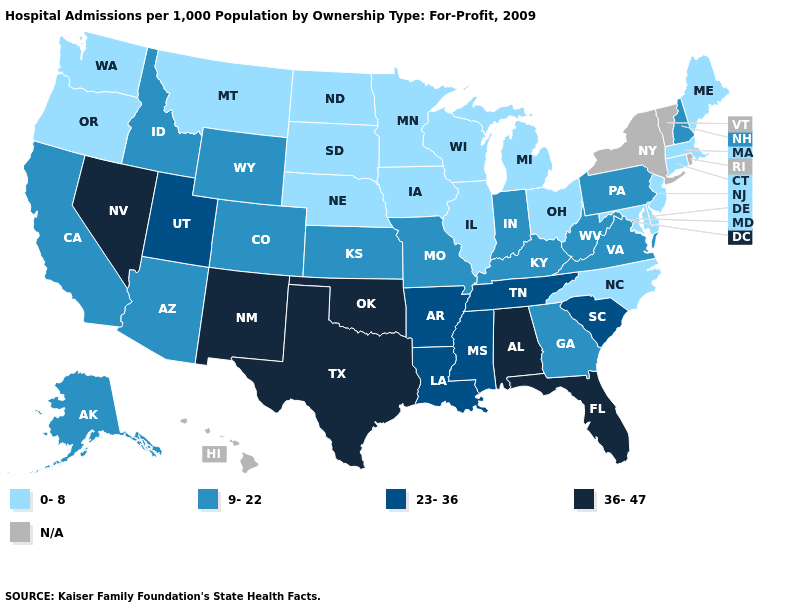Among the states that border Idaho , which have the lowest value?
Quick response, please. Montana, Oregon, Washington. What is the value of Indiana?
Give a very brief answer. 9-22. Which states hav the highest value in the MidWest?
Give a very brief answer. Indiana, Kansas, Missouri. What is the value of North Carolina?
Write a very short answer. 0-8. Which states hav the highest value in the West?
Write a very short answer. Nevada, New Mexico. Among the states that border New York , does Pennsylvania have the highest value?
Give a very brief answer. Yes. Among the states that border Colorado , which have the lowest value?
Be succinct. Nebraska. Name the states that have a value in the range 0-8?
Write a very short answer. Connecticut, Delaware, Illinois, Iowa, Maine, Maryland, Massachusetts, Michigan, Minnesota, Montana, Nebraska, New Jersey, North Carolina, North Dakota, Ohio, Oregon, South Dakota, Washington, Wisconsin. What is the value of Montana?
Be succinct. 0-8. Which states hav the highest value in the West?
Keep it brief. Nevada, New Mexico. Among the states that border Minnesota , which have the lowest value?
Keep it brief. Iowa, North Dakota, South Dakota, Wisconsin. Does the first symbol in the legend represent the smallest category?
Be succinct. Yes. What is the value of Connecticut?
Give a very brief answer. 0-8. 